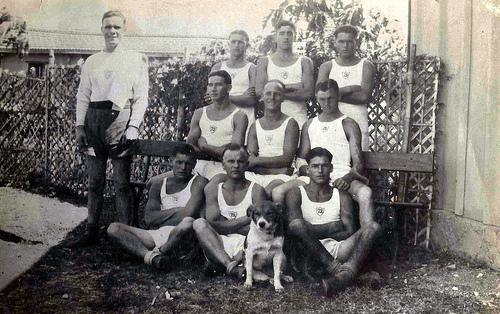Question: who are these men?
Choices:
A. The football team.
B. The chess club.
C. The track team.
D. The marching band.
Answer with the letter. Answer: C Question: why are they sitting?
Choices:
A. For the picture.
B. Because the game is boring.
C. They are tired.
D. They are being respectful.
Answer with the letter. Answer: A Question: how are they dressed?
Choices:
A. White shorts and shirts.
B. Team uniforms.
C. Swim attire.
D. Jeans and Hoodies.
Answer with the letter. Answer: A Question: where are they sitting?
Choices:
A. Behind the bleachers.
B. In front of the fence.
C. On the field.
D. Near the pool.
Answer with the letter. Answer: B Question: what is the man on the left wearing?
Choices:
A. A construction hat.
B. A suit.
C. Black pants.
D. A red tie.
Answer with the letter. Answer: C 